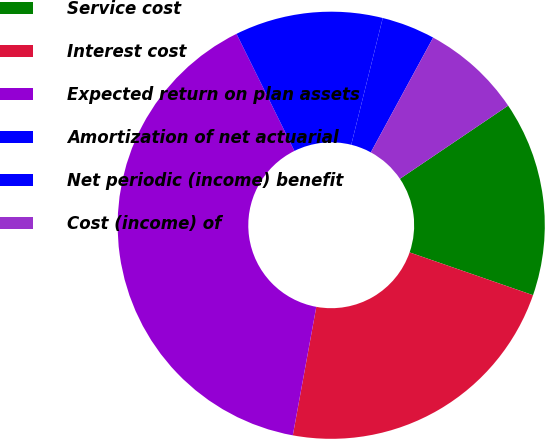Convert chart. <chart><loc_0><loc_0><loc_500><loc_500><pie_chart><fcel>Service cost<fcel>Interest cost<fcel>Expected return on plan assets<fcel>Amortization of net actuarial<fcel>Net periodic (income) benefit<fcel>Cost (income) of<nl><fcel>14.77%<fcel>22.57%<fcel>39.81%<fcel>11.19%<fcel>4.04%<fcel>7.62%<nl></chart> 